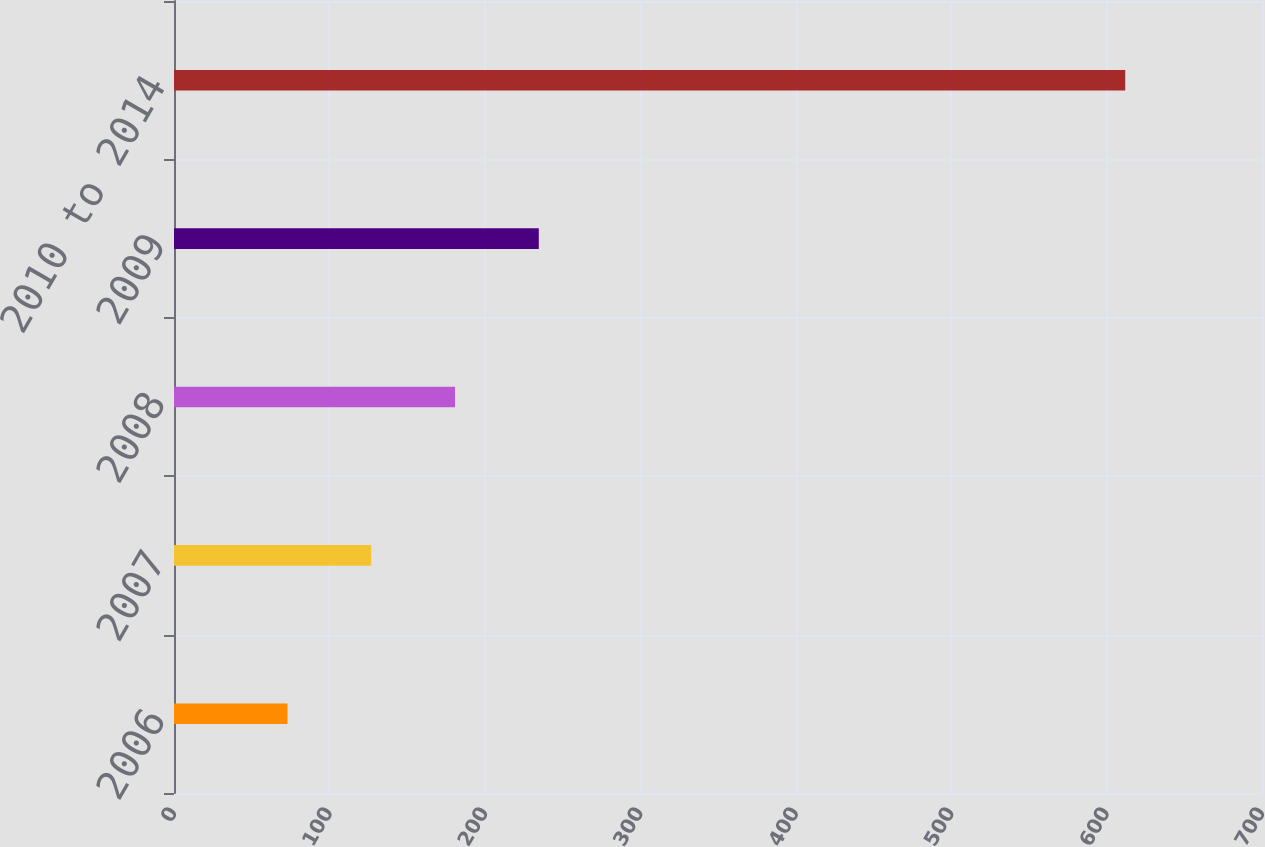Convert chart. <chart><loc_0><loc_0><loc_500><loc_500><bar_chart><fcel>2006<fcel>2007<fcel>2008<fcel>2009<fcel>2010 to 2014<nl><fcel>73<fcel>126.9<fcel>180.8<fcel>234.7<fcel>612<nl></chart> 